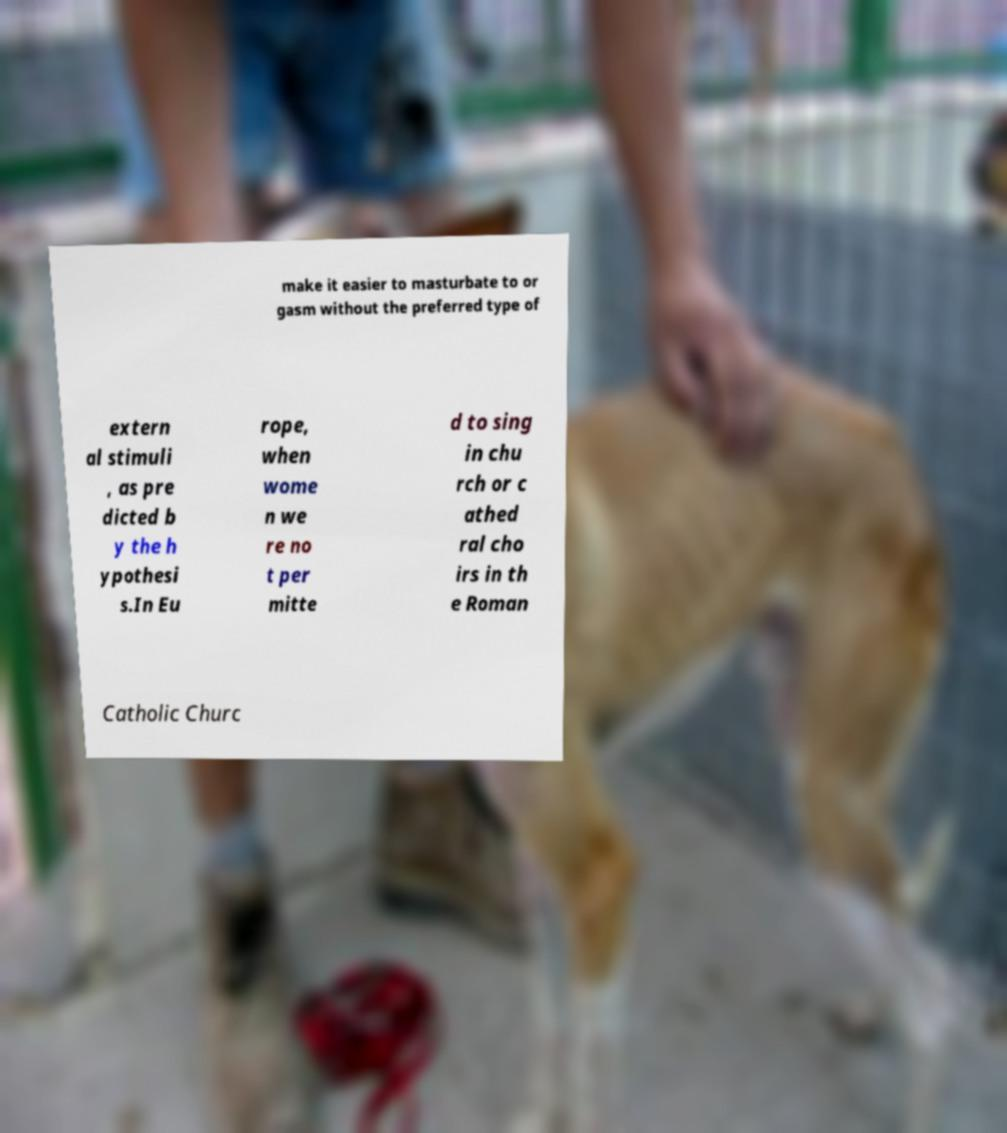I need the written content from this picture converted into text. Can you do that? make it easier to masturbate to or gasm without the preferred type of extern al stimuli , as pre dicted b y the h ypothesi s.In Eu rope, when wome n we re no t per mitte d to sing in chu rch or c athed ral cho irs in th e Roman Catholic Churc 